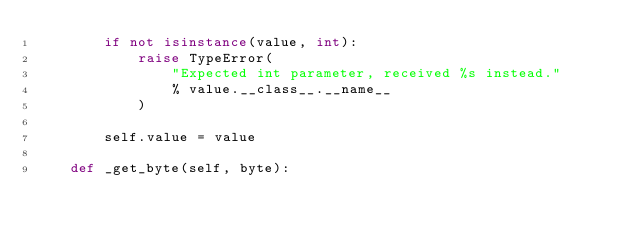Convert code to text. <code><loc_0><loc_0><loc_500><loc_500><_Python_>        if not isinstance(value, int):
            raise TypeError(
                "Expected int parameter, received %s instead."
                % value.__class__.__name__
            )

        self.value = value

    def _get_byte(self, byte):</code> 